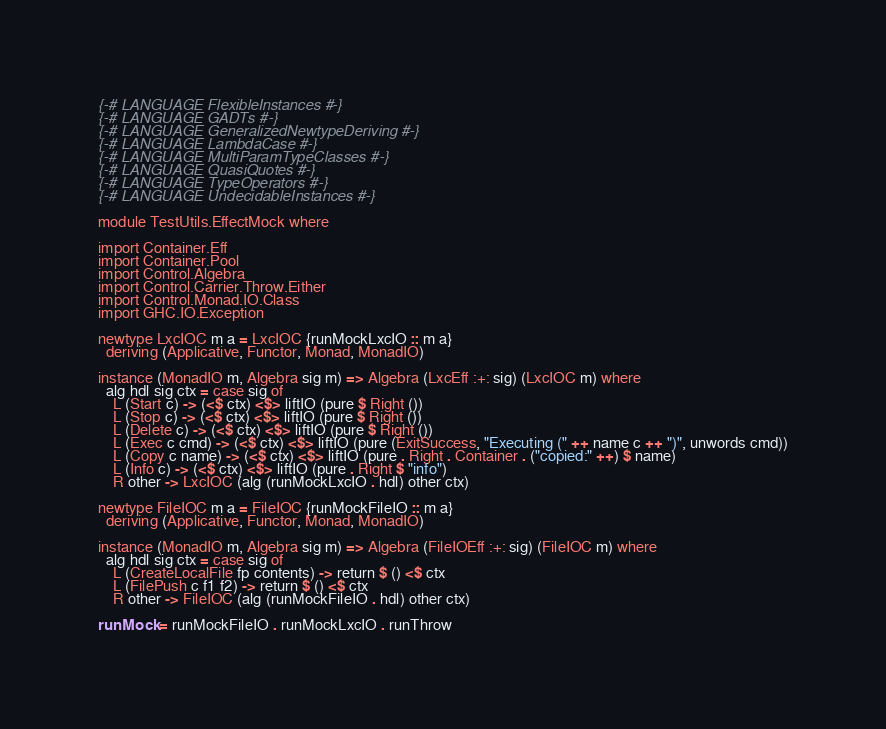Convert code to text. <code><loc_0><loc_0><loc_500><loc_500><_Haskell_>{-# LANGUAGE FlexibleInstances #-}
{-# LANGUAGE GADTs #-}
{-# LANGUAGE GeneralizedNewtypeDeriving #-}
{-# LANGUAGE LambdaCase #-}
{-# LANGUAGE MultiParamTypeClasses #-}
{-# LANGUAGE QuasiQuotes #-}
{-# LANGUAGE TypeOperators #-}
{-# LANGUAGE UndecidableInstances #-}

module TestUtils.EffectMock where

import Container.Eff
import Container.Pool
import Control.Algebra
import Control.Carrier.Throw.Either
import Control.Monad.IO.Class
import GHC.IO.Exception

newtype LxcIOC m a = LxcIOC {runMockLxcIO :: m a}
  deriving (Applicative, Functor, Monad, MonadIO)

instance (MonadIO m, Algebra sig m) => Algebra (LxcEff :+: sig) (LxcIOC m) where
  alg hdl sig ctx = case sig of
    L (Start c) -> (<$ ctx) <$> liftIO (pure $ Right ())
    L (Stop c) -> (<$ ctx) <$> liftIO (pure $ Right ())
    L (Delete c) -> (<$ ctx) <$> liftIO (pure $ Right ())
    L (Exec c cmd) -> (<$ ctx) <$> liftIO (pure (ExitSuccess, "Executing (" ++ name c ++ ")", unwords cmd))
    L (Copy c name) -> (<$ ctx) <$> liftIO (pure . Right . Container . ("copied:" ++) $ name)
    L (Info c) -> (<$ ctx) <$> liftIO (pure . Right $ "info")
    R other -> LxcIOC (alg (runMockLxcIO . hdl) other ctx)

newtype FileIOC m a = FileIOC {runMockFileIO :: m a}
  deriving (Applicative, Functor, Monad, MonadIO)

instance (MonadIO m, Algebra sig m) => Algebra (FileIOEff :+: sig) (FileIOC m) where
  alg hdl sig ctx = case sig of
    L (CreateLocalFile fp contents) -> return $ () <$ ctx
    L (FilePush c f1 f2) -> return $ () <$ ctx
    R other -> FileIOC (alg (runMockFileIO . hdl) other ctx)

runMock = runMockFileIO . runMockLxcIO . runThrow
</code> 